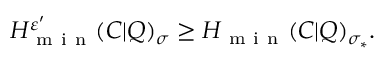Convert formula to latex. <formula><loc_0><loc_0><loc_500><loc_500>H _ { m i n } ^ { \varepsilon ^ { \prime } } ( C | Q ) _ { \sigma } \geq H _ { m i n } ( C | Q ) _ { \sigma _ { \ast } } .</formula> 